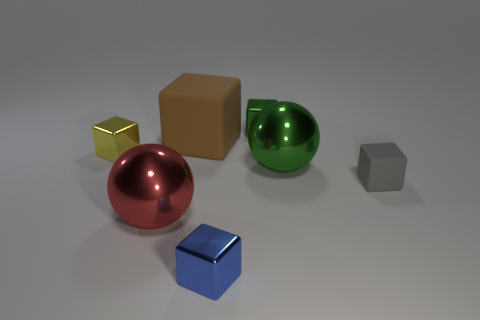Are all the objects in the image solid or are some of them hollow? Based on the image alone, it is not possible to determine with certainty whether the objects are solid or hollow without more information or context. They are depicted as solid in appearance. 